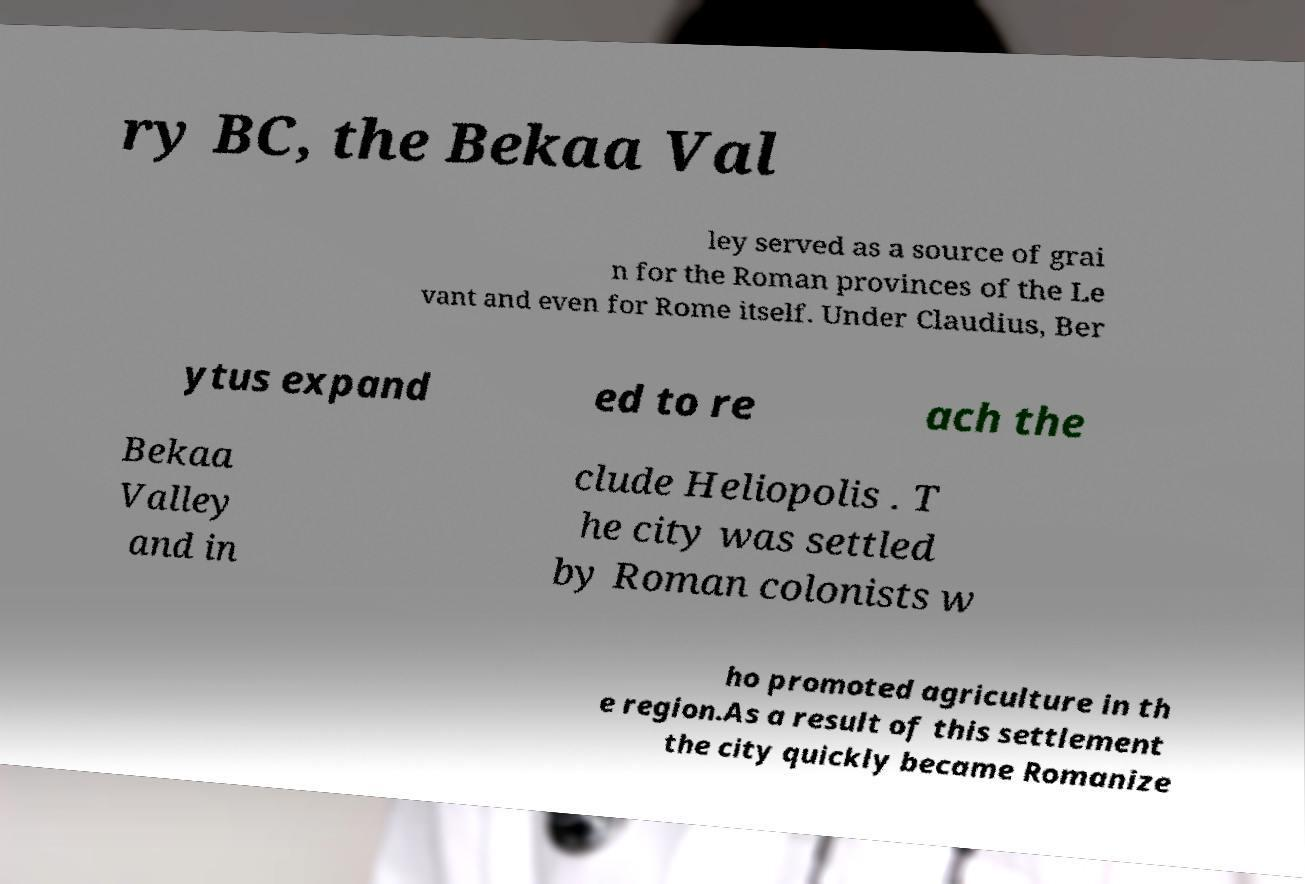Could you assist in decoding the text presented in this image and type it out clearly? ry BC, the Bekaa Val ley served as a source of grai n for the Roman provinces of the Le vant and even for Rome itself. Under Claudius, Ber ytus expand ed to re ach the Bekaa Valley and in clude Heliopolis . T he city was settled by Roman colonists w ho promoted agriculture in th e region.As a result of this settlement the city quickly became Romanize 